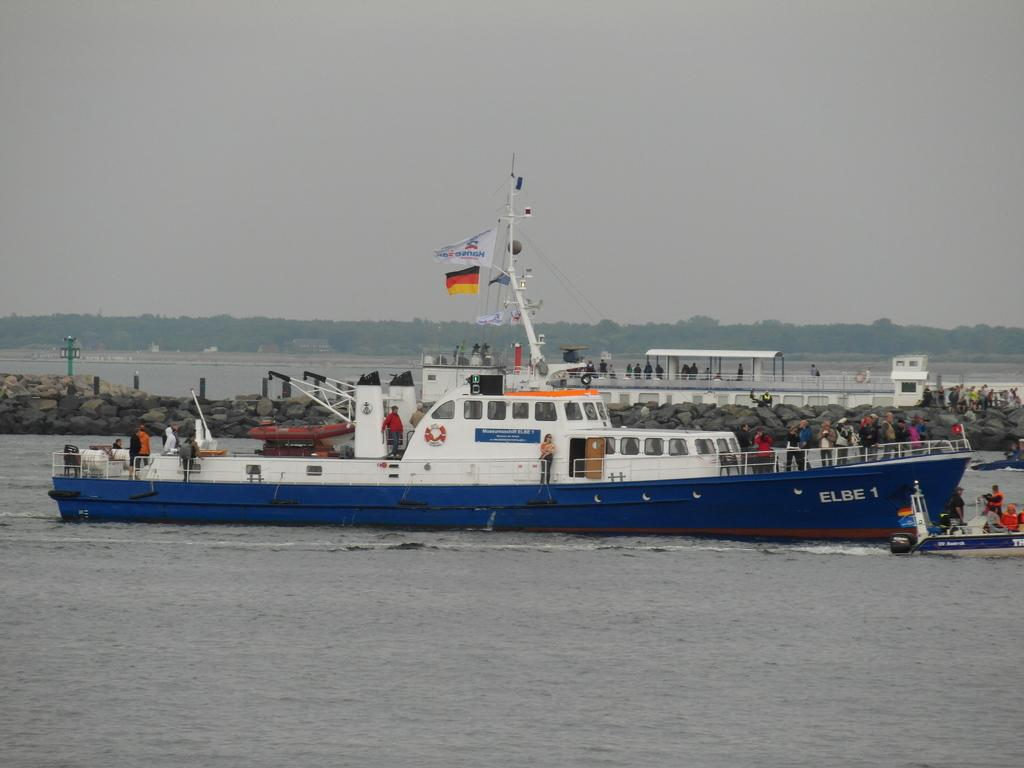What is the main subject of the image? There is a ship in the image. What else can be seen in the image besides the ship? There are people standing in the image, and there are trees and the sky visible in the background. Can you describe the background of the image? In the background, there is a boat, stones, and water. How many people are visible in the image? The number of people is not specified, but there are people standing in the image. What type of calculator is being used by the people in the image? There is no calculator present in the image. How does the stretch of land affect the people in the image? There is no stretch of land mentioned in the image; it features a ship, people, trees, the sky, a boat, stones, and water. 